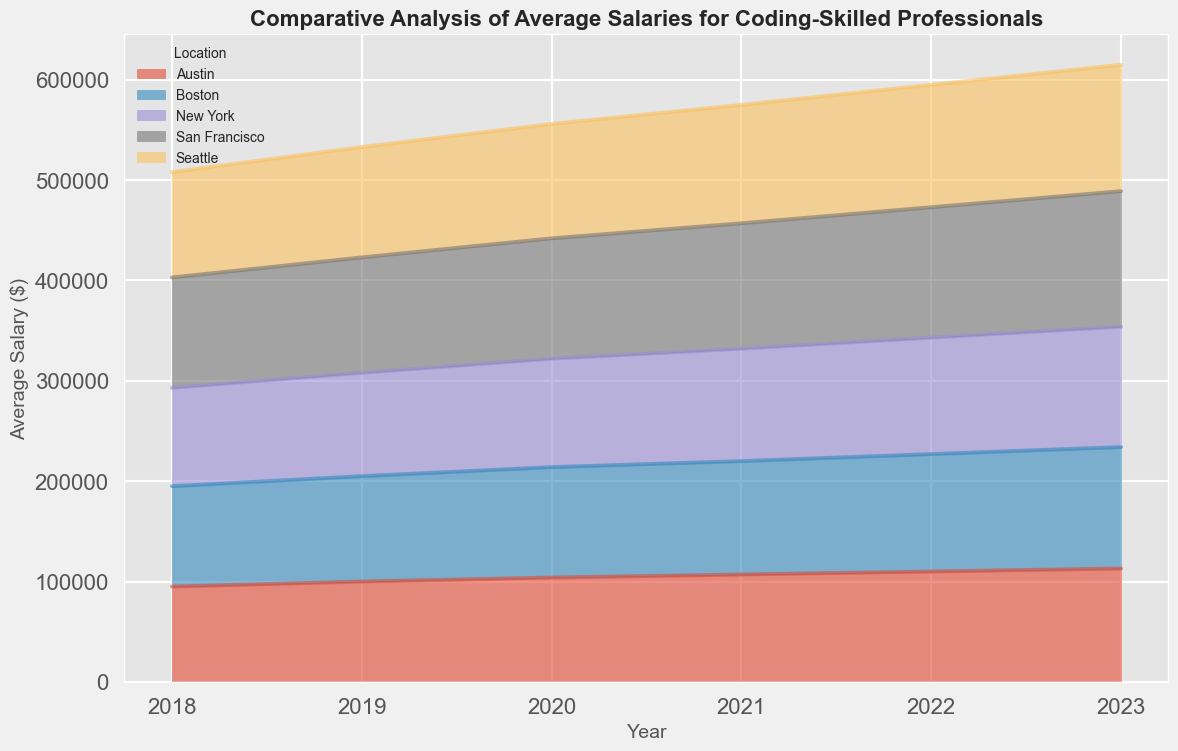Which location had the highest average salary increase from 2018 to 2023? To find the highest average salary increase, we subtract the 2018 average salary from the 2023 average salary for each location: San Francisco (135000 - 110000 = 25000), New York (120000 - 98000 = 22000), Seattle (126000 - 105000 = 21000), Austin (113000 - 95000 = 18000), Boston (121000 - 100000 = 21000). San Francisco has the highest increase.
Answer: San Francisco Which year had the highest average salary across all locations? By examining the area chart, we see that the average salary increases over the years. From the tallest overall height of the salary areas in the chart, 2023 has the highest overall average salaries.
Answer: 2023 Was there a year when the average salary for coding-skilled professionals in Seattle exceeded that of New York? Comparing the graph lines of Seattle and New York, Seattle's area was consistently above New York's area starting from 2020 onward.
Answer: Yes, from 2020 onward Did Austin experience a year with no salary increase? By checking the visual heights (areas) for Austin, every year shows an increase in salary over the previous year.
Answer: No How did the average salary in Boston change from 2019 to 2022? To track the change, observe Boston’s area from 2019 at 105000 to 2022 at 117000. The salary increased by 12000 (117000 - 105000) over these years.
Answer: Increased by $12000 Which location had the least average salary in 2022? By examining the lowest points on the 2022 area chart, Austin's height indicates the lowest value, which is 110000.
Answer: Austin How does the trend in average salaries in San Francisco compare to that in Boston? Visually, both San Francisco and Boston show increasing trends over the years. San Francisco's area, however, increases more steeply compared to Boston's, indicating a higher salary growth rate.
Answer: San Francisco increased more steeply What is the difference between the highest and lowest average salaries for San Francisco over the given years? The highest average salary for San Francisco in 2023 is 135000, and the lowest in 2018 is 110000. The difference is 135000 - 110000 = 25000.
Answer: $25000 Do any two cities have the same average salary in any year? Check over the graph areas to see if any overlaps in the same year occur. There are no overlaps in the exact same year among the cities.
Answer: No By what percentage did the average salary in New York increase from 2018 to 2023? Calculate the percentage increase: ((120000 - 98000) / 98000) * 100 = 22.45%.
Answer: 22.45% 